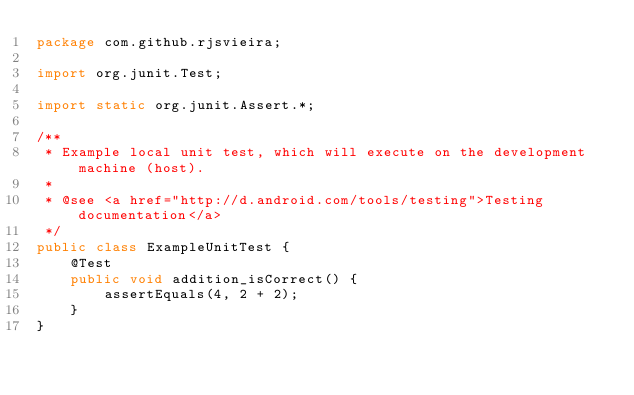Convert code to text. <code><loc_0><loc_0><loc_500><loc_500><_Java_>package com.github.rjsvieira;

import org.junit.Test;

import static org.junit.Assert.*;

/**
 * Example local unit test, which will execute on the development machine (host).
 *
 * @see <a href="http://d.android.com/tools/testing">Testing documentation</a>
 */
public class ExampleUnitTest {
    @Test
    public void addition_isCorrect() {
        assertEquals(4, 2 + 2);
    }
}</code> 